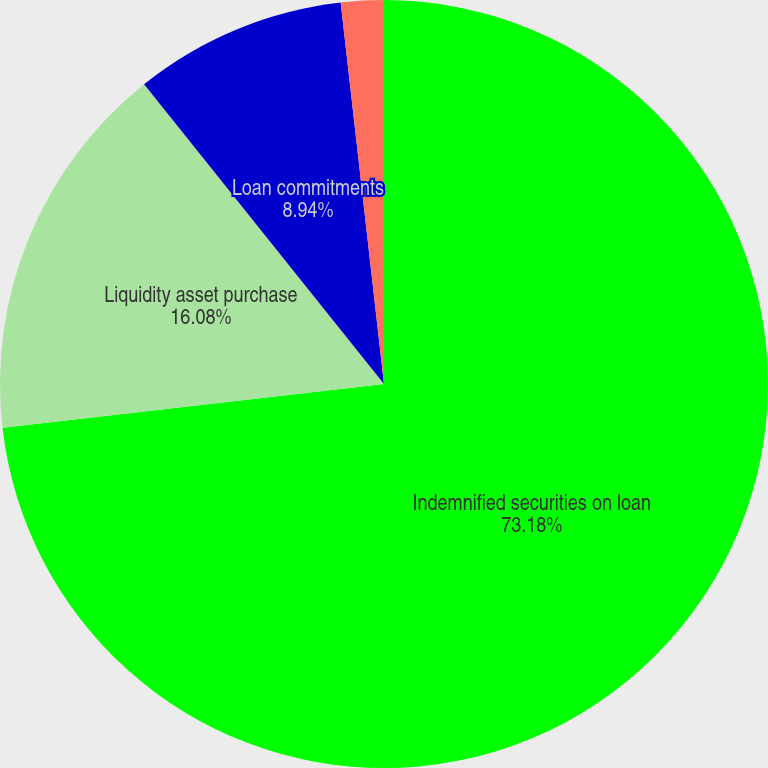<chart> <loc_0><loc_0><loc_500><loc_500><pie_chart><fcel>Indemnified securities on loan<fcel>Liquidity asset purchase<fcel>Loan commitments<fcel>Standby letters of credit<nl><fcel>73.18%<fcel>16.08%<fcel>8.94%<fcel>1.8%<nl></chart> 